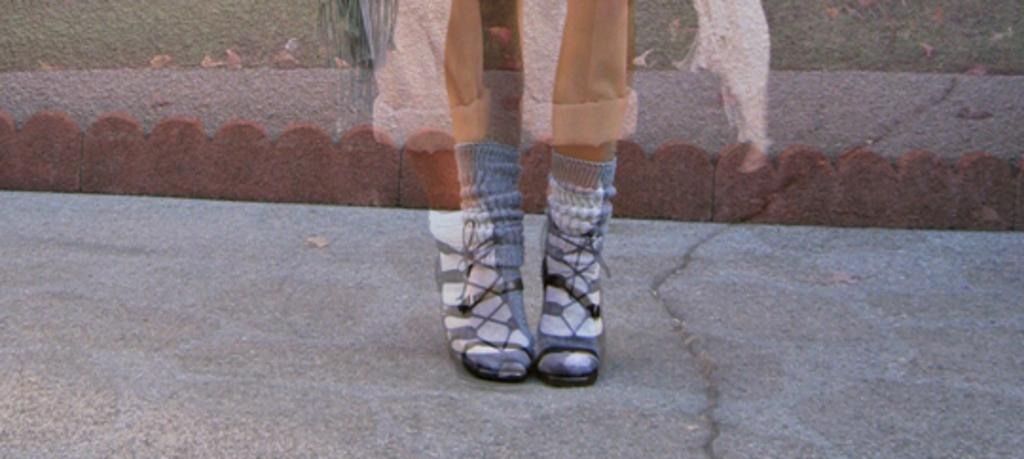What part of a person can be seen in the image? There are legs of a person visible in the image. Can you describe the quality of the image? The image appears to be blurry. What type of wound can be seen on the person's leg in the image? There is no wound visible on the person's leg in the image. What type of bird is sitting on the handlebars of the bike in the image? There is no bike or bird present in the image. What type of tool is the wren using to fix the wires in the image? There is no wren or wires present in the image. 